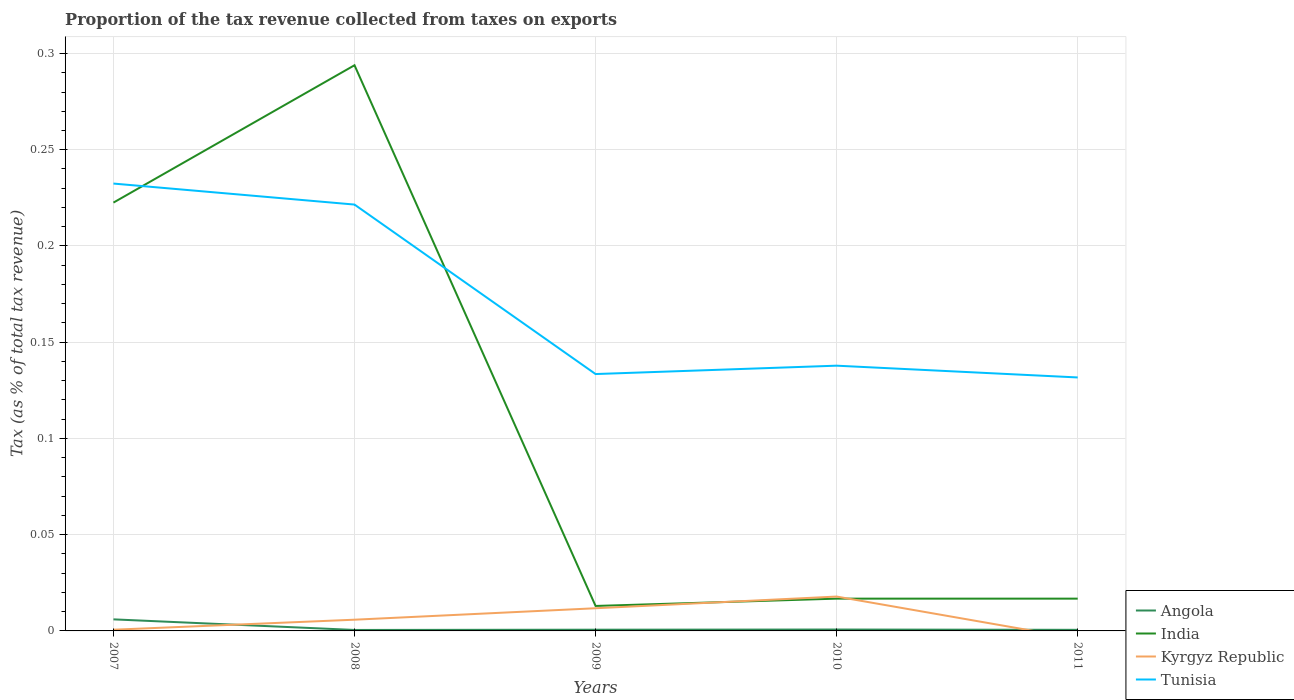Across all years, what is the maximum proportion of the tax revenue collected in Angola?
Ensure brevity in your answer.  0. What is the total proportion of the tax revenue collected in Tunisia in the graph?
Your answer should be very brief. -0. What is the difference between the highest and the second highest proportion of the tax revenue collected in Kyrgyz Republic?
Provide a short and direct response. 0.02. How many years are there in the graph?
Make the answer very short. 5. What is the difference between two consecutive major ticks on the Y-axis?
Keep it short and to the point. 0.05. Does the graph contain any zero values?
Offer a very short reply. Yes. Does the graph contain grids?
Offer a very short reply. Yes. Where does the legend appear in the graph?
Provide a short and direct response. Bottom right. How many legend labels are there?
Your response must be concise. 4. How are the legend labels stacked?
Your response must be concise. Vertical. What is the title of the graph?
Keep it short and to the point. Proportion of the tax revenue collected from taxes on exports. What is the label or title of the Y-axis?
Make the answer very short. Tax (as % of total tax revenue). What is the Tax (as % of total tax revenue) in Angola in 2007?
Provide a succinct answer. 0.01. What is the Tax (as % of total tax revenue) in India in 2007?
Offer a terse response. 0.22. What is the Tax (as % of total tax revenue) of Kyrgyz Republic in 2007?
Offer a very short reply. 0. What is the Tax (as % of total tax revenue) in Tunisia in 2007?
Give a very brief answer. 0.23. What is the Tax (as % of total tax revenue) in Angola in 2008?
Offer a very short reply. 0. What is the Tax (as % of total tax revenue) of India in 2008?
Provide a succinct answer. 0.29. What is the Tax (as % of total tax revenue) of Kyrgyz Republic in 2008?
Provide a short and direct response. 0.01. What is the Tax (as % of total tax revenue) of Tunisia in 2008?
Your answer should be very brief. 0.22. What is the Tax (as % of total tax revenue) of Angola in 2009?
Your answer should be compact. 0. What is the Tax (as % of total tax revenue) of India in 2009?
Keep it short and to the point. 0.01. What is the Tax (as % of total tax revenue) of Kyrgyz Republic in 2009?
Give a very brief answer. 0.01. What is the Tax (as % of total tax revenue) of Tunisia in 2009?
Provide a succinct answer. 0.13. What is the Tax (as % of total tax revenue) in Angola in 2010?
Provide a succinct answer. 0. What is the Tax (as % of total tax revenue) in India in 2010?
Keep it short and to the point. 0.02. What is the Tax (as % of total tax revenue) in Kyrgyz Republic in 2010?
Offer a very short reply. 0.02. What is the Tax (as % of total tax revenue) of Tunisia in 2010?
Your answer should be compact. 0.14. What is the Tax (as % of total tax revenue) of Angola in 2011?
Offer a terse response. 0. What is the Tax (as % of total tax revenue) in India in 2011?
Offer a terse response. 0.02. What is the Tax (as % of total tax revenue) in Kyrgyz Republic in 2011?
Ensure brevity in your answer.  0. What is the Tax (as % of total tax revenue) of Tunisia in 2011?
Make the answer very short. 0.13. Across all years, what is the maximum Tax (as % of total tax revenue) of Angola?
Provide a short and direct response. 0.01. Across all years, what is the maximum Tax (as % of total tax revenue) in India?
Ensure brevity in your answer.  0.29. Across all years, what is the maximum Tax (as % of total tax revenue) of Kyrgyz Republic?
Offer a terse response. 0.02. Across all years, what is the maximum Tax (as % of total tax revenue) of Tunisia?
Offer a very short reply. 0.23. Across all years, what is the minimum Tax (as % of total tax revenue) in Angola?
Ensure brevity in your answer.  0. Across all years, what is the minimum Tax (as % of total tax revenue) of India?
Offer a terse response. 0.01. Across all years, what is the minimum Tax (as % of total tax revenue) in Kyrgyz Republic?
Your answer should be compact. 0. Across all years, what is the minimum Tax (as % of total tax revenue) of Tunisia?
Provide a short and direct response. 0.13. What is the total Tax (as % of total tax revenue) of Angola in the graph?
Your answer should be very brief. 0.01. What is the total Tax (as % of total tax revenue) in India in the graph?
Provide a succinct answer. 0.56. What is the total Tax (as % of total tax revenue) in Kyrgyz Republic in the graph?
Your response must be concise. 0.04. What is the total Tax (as % of total tax revenue) in Tunisia in the graph?
Your answer should be very brief. 0.86. What is the difference between the Tax (as % of total tax revenue) of Angola in 2007 and that in 2008?
Ensure brevity in your answer.  0.01. What is the difference between the Tax (as % of total tax revenue) of India in 2007 and that in 2008?
Your answer should be compact. -0.07. What is the difference between the Tax (as % of total tax revenue) of Kyrgyz Republic in 2007 and that in 2008?
Provide a short and direct response. -0.01. What is the difference between the Tax (as % of total tax revenue) in Tunisia in 2007 and that in 2008?
Provide a short and direct response. 0.01. What is the difference between the Tax (as % of total tax revenue) in Angola in 2007 and that in 2009?
Provide a short and direct response. 0.01. What is the difference between the Tax (as % of total tax revenue) of India in 2007 and that in 2009?
Your answer should be compact. 0.21. What is the difference between the Tax (as % of total tax revenue) of Kyrgyz Republic in 2007 and that in 2009?
Provide a succinct answer. -0.01. What is the difference between the Tax (as % of total tax revenue) of Tunisia in 2007 and that in 2009?
Your answer should be compact. 0.1. What is the difference between the Tax (as % of total tax revenue) of Angola in 2007 and that in 2010?
Make the answer very short. 0.01. What is the difference between the Tax (as % of total tax revenue) in India in 2007 and that in 2010?
Your answer should be compact. 0.21. What is the difference between the Tax (as % of total tax revenue) of Kyrgyz Republic in 2007 and that in 2010?
Your response must be concise. -0.02. What is the difference between the Tax (as % of total tax revenue) in Tunisia in 2007 and that in 2010?
Keep it short and to the point. 0.09. What is the difference between the Tax (as % of total tax revenue) of Angola in 2007 and that in 2011?
Make the answer very short. 0.01. What is the difference between the Tax (as % of total tax revenue) in India in 2007 and that in 2011?
Make the answer very short. 0.21. What is the difference between the Tax (as % of total tax revenue) in Tunisia in 2007 and that in 2011?
Offer a terse response. 0.1. What is the difference between the Tax (as % of total tax revenue) in Angola in 2008 and that in 2009?
Your answer should be compact. -0. What is the difference between the Tax (as % of total tax revenue) in India in 2008 and that in 2009?
Offer a very short reply. 0.28. What is the difference between the Tax (as % of total tax revenue) in Kyrgyz Republic in 2008 and that in 2009?
Keep it short and to the point. -0.01. What is the difference between the Tax (as % of total tax revenue) of Tunisia in 2008 and that in 2009?
Your answer should be very brief. 0.09. What is the difference between the Tax (as % of total tax revenue) of Angola in 2008 and that in 2010?
Provide a short and direct response. -0. What is the difference between the Tax (as % of total tax revenue) in India in 2008 and that in 2010?
Offer a very short reply. 0.28. What is the difference between the Tax (as % of total tax revenue) in Kyrgyz Republic in 2008 and that in 2010?
Provide a succinct answer. -0.01. What is the difference between the Tax (as % of total tax revenue) of Tunisia in 2008 and that in 2010?
Offer a terse response. 0.08. What is the difference between the Tax (as % of total tax revenue) of Angola in 2008 and that in 2011?
Your answer should be compact. -0. What is the difference between the Tax (as % of total tax revenue) in India in 2008 and that in 2011?
Provide a short and direct response. 0.28. What is the difference between the Tax (as % of total tax revenue) in Tunisia in 2008 and that in 2011?
Make the answer very short. 0.09. What is the difference between the Tax (as % of total tax revenue) in Angola in 2009 and that in 2010?
Give a very brief answer. -0. What is the difference between the Tax (as % of total tax revenue) in India in 2009 and that in 2010?
Ensure brevity in your answer.  -0. What is the difference between the Tax (as % of total tax revenue) of Kyrgyz Republic in 2009 and that in 2010?
Ensure brevity in your answer.  -0.01. What is the difference between the Tax (as % of total tax revenue) in Tunisia in 2009 and that in 2010?
Offer a terse response. -0. What is the difference between the Tax (as % of total tax revenue) of Angola in 2009 and that in 2011?
Your answer should be compact. 0. What is the difference between the Tax (as % of total tax revenue) of India in 2009 and that in 2011?
Your response must be concise. -0. What is the difference between the Tax (as % of total tax revenue) in Tunisia in 2009 and that in 2011?
Keep it short and to the point. 0. What is the difference between the Tax (as % of total tax revenue) of Tunisia in 2010 and that in 2011?
Offer a very short reply. 0.01. What is the difference between the Tax (as % of total tax revenue) of Angola in 2007 and the Tax (as % of total tax revenue) of India in 2008?
Provide a succinct answer. -0.29. What is the difference between the Tax (as % of total tax revenue) in Angola in 2007 and the Tax (as % of total tax revenue) in Kyrgyz Republic in 2008?
Offer a very short reply. 0. What is the difference between the Tax (as % of total tax revenue) of Angola in 2007 and the Tax (as % of total tax revenue) of Tunisia in 2008?
Offer a very short reply. -0.22. What is the difference between the Tax (as % of total tax revenue) of India in 2007 and the Tax (as % of total tax revenue) of Kyrgyz Republic in 2008?
Offer a very short reply. 0.22. What is the difference between the Tax (as % of total tax revenue) in India in 2007 and the Tax (as % of total tax revenue) in Tunisia in 2008?
Offer a very short reply. 0. What is the difference between the Tax (as % of total tax revenue) in Kyrgyz Republic in 2007 and the Tax (as % of total tax revenue) in Tunisia in 2008?
Keep it short and to the point. -0.22. What is the difference between the Tax (as % of total tax revenue) in Angola in 2007 and the Tax (as % of total tax revenue) in India in 2009?
Offer a terse response. -0.01. What is the difference between the Tax (as % of total tax revenue) of Angola in 2007 and the Tax (as % of total tax revenue) of Kyrgyz Republic in 2009?
Your response must be concise. -0.01. What is the difference between the Tax (as % of total tax revenue) of Angola in 2007 and the Tax (as % of total tax revenue) of Tunisia in 2009?
Your answer should be compact. -0.13. What is the difference between the Tax (as % of total tax revenue) of India in 2007 and the Tax (as % of total tax revenue) of Kyrgyz Republic in 2009?
Offer a very short reply. 0.21. What is the difference between the Tax (as % of total tax revenue) in India in 2007 and the Tax (as % of total tax revenue) in Tunisia in 2009?
Offer a very short reply. 0.09. What is the difference between the Tax (as % of total tax revenue) of Kyrgyz Republic in 2007 and the Tax (as % of total tax revenue) of Tunisia in 2009?
Provide a short and direct response. -0.13. What is the difference between the Tax (as % of total tax revenue) of Angola in 2007 and the Tax (as % of total tax revenue) of India in 2010?
Your answer should be compact. -0.01. What is the difference between the Tax (as % of total tax revenue) of Angola in 2007 and the Tax (as % of total tax revenue) of Kyrgyz Republic in 2010?
Make the answer very short. -0.01. What is the difference between the Tax (as % of total tax revenue) in Angola in 2007 and the Tax (as % of total tax revenue) in Tunisia in 2010?
Offer a very short reply. -0.13. What is the difference between the Tax (as % of total tax revenue) in India in 2007 and the Tax (as % of total tax revenue) in Kyrgyz Republic in 2010?
Offer a terse response. 0.2. What is the difference between the Tax (as % of total tax revenue) in India in 2007 and the Tax (as % of total tax revenue) in Tunisia in 2010?
Provide a short and direct response. 0.08. What is the difference between the Tax (as % of total tax revenue) in Kyrgyz Republic in 2007 and the Tax (as % of total tax revenue) in Tunisia in 2010?
Offer a terse response. -0.14. What is the difference between the Tax (as % of total tax revenue) of Angola in 2007 and the Tax (as % of total tax revenue) of India in 2011?
Ensure brevity in your answer.  -0.01. What is the difference between the Tax (as % of total tax revenue) of Angola in 2007 and the Tax (as % of total tax revenue) of Tunisia in 2011?
Your response must be concise. -0.13. What is the difference between the Tax (as % of total tax revenue) of India in 2007 and the Tax (as % of total tax revenue) of Tunisia in 2011?
Offer a very short reply. 0.09. What is the difference between the Tax (as % of total tax revenue) in Kyrgyz Republic in 2007 and the Tax (as % of total tax revenue) in Tunisia in 2011?
Keep it short and to the point. -0.13. What is the difference between the Tax (as % of total tax revenue) in Angola in 2008 and the Tax (as % of total tax revenue) in India in 2009?
Your answer should be very brief. -0.01. What is the difference between the Tax (as % of total tax revenue) of Angola in 2008 and the Tax (as % of total tax revenue) of Kyrgyz Republic in 2009?
Offer a terse response. -0.01. What is the difference between the Tax (as % of total tax revenue) of Angola in 2008 and the Tax (as % of total tax revenue) of Tunisia in 2009?
Your answer should be very brief. -0.13. What is the difference between the Tax (as % of total tax revenue) in India in 2008 and the Tax (as % of total tax revenue) in Kyrgyz Republic in 2009?
Make the answer very short. 0.28. What is the difference between the Tax (as % of total tax revenue) in India in 2008 and the Tax (as % of total tax revenue) in Tunisia in 2009?
Offer a terse response. 0.16. What is the difference between the Tax (as % of total tax revenue) of Kyrgyz Republic in 2008 and the Tax (as % of total tax revenue) of Tunisia in 2009?
Your answer should be compact. -0.13. What is the difference between the Tax (as % of total tax revenue) in Angola in 2008 and the Tax (as % of total tax revenue) in India in 2010?
Provide a succinct answer. -0.02. What is the difference between the Tax (as % of total tax revenue) of Angola in 2008 and the Tax (as % of total tax revenue) of Kyrgyz Republic in 2010?
Your answer should be very brief. -0.02. What is the difference between the Tax (as % of total tax revenue) of Angola in 2008 and the Tax (as % of total tax revenue) of Tunisia in 2010?
Ensure brevity in your answer.  -0.14. What is the difference between the Tax (as % of total tax revenue) of India in 2008 and the Tax (as % of total tax revenue) of Kyrgyz Republic in 2010?
Make the answer very short. 0.28. What is the difference between the Tax (as % of total tax revenue) of India in 2008 and the Tax (as % of total tax revenue) of Tunisia in 2010?
Make the answer very short. 0.16. What is the difference between the Tax (as % of total tax revenue) of Kyrgyz Republic in 2008 and the Tax (as % of total tax revenue) of Tunisia in 2010?
Your answer should be very brief. -0.13. What is the difference between the Tax (as % of total tax revenue) of Angola in 2008 and the Tax (as % of total tax revenue) of India in 2011?
Your response must be concise. -0.02. What is the difference between the Tax (as % of total tax revenue) of Angola in 2008 and the Tax (as % of total tax revenue) of Tunisia in 2011?
Give a very brief answer. -0.13. What is the difference between the Tax (as % of total tax revenue) in India in 2008 and the Tax (as % of total tax revenue) in Tunisia in 2011?
Provide a short and direct response. 0.16. What is the difference between the Tax (as % of total tax revenue) in Kyrgyz Republic in 2008 and the Tax (as % of total tax revenue) in Tunisia in 2011?
Ensure brevity in your answer.  -0.13. What is the difference between the Tax (as % of total tax revenue) in Angola in 2009 and the Tax (as % of total tax revenue) in India in 2010?
Make the answer very short. -0.02. What is the difference between the Tax (as % of total tax revenue) of Angola in 2009 and the Tax (as % of total tax revenue) of Kyrgyz Republic in 2010?
Keep it short and to the point. -0.02. What is the difference between the Tax (as % of total tax revenue) in Angola in 2009 and the Tax (as % of total tax revenue) in Tunisia in 2010?
Offer a very short reply. -0.14. What is the difference between the Tax (as % of total tax revenue) of India in 2009 and the Tax (as % of total tax revenue) of Kyrgyz Republic in 2010?
Your answer should be compact. -0. What is the difference between the Tax (as % of total tax revenue) in India in 2009 and the Tax (as % of total tax revenue) in Tunisia in 2010?
Ensure brevity in your answer.  -0.12. What is the difference between the Tax (as % of total tax revenue) of Kyrgyz Republic in 2009 and the Tax (as % of total tax revenue) of Tunisia in 2010?
Ensure brevity in your answer.  -0.13. What is the difference between the Tax (as % of total tax revenue) in Angola in 2009 and the Tax (as % of total tax revenue) in India in 2011?
Provide a short and direct response. -0.02. What is the difference between the Tax (as % of total tax revenue) in Angola in 2009 and the Tax (as % of total tax revenue) in Tunisia in 2011?
Your response must be concise. -0.13. What is the difference between the Tax (as % of total tax revenue) of India in 2009 and the Tax (as % of total tax revenue) of Tunisia in 2011?
Your response must be concise. -0.12. What is the difference between the Tax (as % of total tax revenue) of Kyrgyz Republic in 2009 and the Tax (as % of total tax revenue) of Tunisia in 2011?
Your answer should be compact. -0.12. What is the difference between the Tax (as % of total tax revenue) of Angola in 2010 and the Tax (as % of total tax revenue) of India in 2011?
Offer a terse response. -0.02. What is the difference between the Tax (as % of total tax revenue) in Angola in 2010 and the Tax (as % of total tax revenue) in Tunisia in 2011?
Provide a short and direct response. -0.13. What is the difference between the Tax (as % of total tax revenue) of India in 2010 and the Tax (as % of total tax revenue) of Tunisia in 2011?
Provide a succinct answer. -0.11. What is the difference between the Tax (as % of total tax revenue) of Kyrgyz Republic in 2010 and the Tax (as % of total tax revenue) of Tunisia in 2011?
Provide a succinct answer. -0.11. What is the average Tax (as % of total tax revenue) in Angola per year?
Keep it short and to the point. 0. What is the average Tax (as % of total tax revenue) of India per year?
Provide a succinct answer. 0.11. What is the average Tax (as % of total tax revenue) of Kyrgyz Republic per year?
Your answer should be compact. 0.01. What is the average Tax (as % of total tax revenue) in Tunisia per year?
Ensure brevity in your answer.  0.17. In the year 2007, what is the difference between the Tax (as % of total tax revenue) of Angola and Tax (as % of total tax revenue) of India?
Give a very brief answer. -0.22. In the year 2007, what is the difference between the Tax (as % of total tax revenue) in Angola and Tax (as % of total tax revenue) in Kyrgyz Republic?
Your response must be concise. 0.01. In the year 2007, what is the difference between the Tax (as % of total tax revenue) of Angola and Tax (as % of total tax revenue) of Tunisia?
Make the answer very short. -0.23. In the year 2007, what is the difference between the Tax (as % of total tax revenue) in India and Tax (as % of total tax revenue) in Kyrgyz Republic?
Make the answer very short. 0.22. In the year 2007, what is the difference between the Tax (as % of total tax revenue) in India and Tax (as % of total tax revenue) in Tunisia?
Your answer should be compact. -0.01. In the year 2007, what is the difference between the Tax (as % of total tax revenue) in Kyrgyz Republic and Tax (as % of total tax revenue) in Tunisia?
Provide a short and direct response. -0.23. In the year 2008, what is the difference between the Tax (as % of total tax revenue) of Angola and Tax (as % of total tax revenue) of India?
Make the answer very short. -0.29. In the year 2008, what is the difference between the Tax (as % of total tax revenue) of Angola and Tax (as % of total tax revenue) of Kyrgyz Republic?
Your answer should be very brief. -0.01. In the year 2008, what is the difference between the Tax (as % of total tax revenue) of Angola and Tax (as % of total tax revenue) of Tunisia?
Provide a succinct answer. -0.22. In the year 2008, what is the difference between the Tax (as % of total tax revenue) in India and Tax (as % of total tax revenue) in Kyrgyz Republic?
Make the answer very short. 0.29. In the year 2008, what is the difference between the Tax (as % of total tax revenue) in India and Tax (as % of total tax revenue) in Tunisia?
Give a very brief answer. 0.07. In the year 2008, what is the difference between the Tax (as % of total tax revenue) in Kyrgyz Republic and Tax (as % of total tax revenue) in Tunisia?
Provide a succinct answer. -0.22. In the year 2009, what is the difference between the Tax (as % of total tax revenue) in Angola and Tax (as % of total tax revenue) in India?
Offer a very short reply. -0.01. In the year 2009, what is the difference between the Tax (as % of total tax revenue) of Angola and Tax (as % of total tax revenue) of Kyrgyz Republic?
Give a very brief answer. -0.01. In the year 2009, what is the difference between the Tax (as % of total tax revenue) in Angola and Tax (as % of total tax revenue) in Tunisia?
Give a very brief answer. -0.13. In the year 2009, what is the difference between the Tax (as % of total tax revenue) of India and Tax (as % of total tax revenue) of Kyrgyz Republic?
Provide a short and direct response. 0. In the year 2009, what is the difference between the Tax (as % of total tax revenue) in India and Tax (as % of total tax revenue) in Tunisia?
Keep it short and to the point. -0.12. In the year 2009, what is the difference between the Tax (as % of total tax revenue) of Kyrgyz Republic and Tax (as % of total tax revenue) of Tunisia?
Provide a succinct answer. -0.12. In the year 2010, what is the difference between the Tax (as % of total tax revenue) of Angola and Tax (as % of total tax revenue) of India?
Ensure brevity in your answer.  -0.02. In the year 2010, what is the difference between the Tax (as % of total tax revenue) in Angola and Tax (as % of total tax revenue) in Kyrgyz Republic?
Give a very brief answer. -0.02. In the year 2010, what is the difference between the Tax (as % of total tax revenue) of Angola and Tax (as % of total tax revenue) of Tunisia?
Your answer should be compact. -0.14. In the year 2010, what is the difference between the Tax (as % of total tax revenue) in India and Tax (as % of total tax revenue) in Kyrgyz Republic?
Provide a succinct answer. -0. In the year 2010, what is the difference between the Tax (as % of total tax revenue) of India and Tax (as % of total tax revenue) of Tunisia?
Your response must be concise. -0.12. In the year 2010, what is the difference between the Tax (as % of total tax revenue) of Kyrgyz Republic and Tax (as % of total tax revenue) of Tunisia?
Your answer should be compact. -0.12. In the year 2011, what is the difference between the Tax (as % of total tax revenue) of Angola and Tax (as % of total tax revenue) of India?
Provide a short and direct response. -0.02. In the year 2011, what is the difference between the Tax (as % of total tax revenue) in Angola and Tax (as % of total tax revenue) in Tunisia?
Provide a succinct answer. -0.13. In the year 2011, what is the difference between the Tax (as % of total tax revenue) of India and Tax (as % of total tax revenue) of Tunisia?
Your answer should be very brief. -0.11. What is the ratio of the Tax (as % of total tax revenue) of Angola in 2007 to that in 2008?
Your answer should be very brief. 11.89. What is the ratio of the Tax (as % of total tax revenue) of India in 2007 to that in 2008?
Your answer should be very brief. 0.76. What is the ratio of the Tax (as % of total tax revenue) in Kyrgyz Republic in 2007 to that in 2008?
Offer a very short reply. 0.11. What is the ratio of the Tax (as % of total tax revenue) in Tunisia in 2007 to that in 2008?
Give a very brief answer. 1.05. What is the ratio of the Tax (as % of total tax revenue) of Angola in 2007 to that in 2009?
Your answer should be compact. 9.5. What is the ratio of the Tax (as % of total tax revenue) in India in 2007 to that in 2009?
Give a very brief answer. 17.16. What is the ratio of the Tax (as % of total tax revenue) of Kyrgyz Republic in 2007 to that in 2009?
Your answer should be very brief. 0.05. What is the ratio of the Tax (as % of total tax revenue) in Tunisia in 2007 to that in 2009?
Your answer should be compact. 1.74. What is the ratio of the Tax (as % of total tax revenue) in Angola in 2007 to that in 2010?
Provide a succinct answer. 8.31. What is the ratio of the Tax (as % of total tax revenue) in India in 2007 to that in 2010?
Offer a terse response. 13.27. What is the ratio of the Tax (as % of total tax revenue) of Kyrgyz Republic in 2007 to that in 2010?
Provide a succinct answer. 0.04. What is the ratio of the Tax (as % of total tax revenue) in Tunisia in 2007 to that in 2010?
Provide a short and direct response. 1.69. What is the ratio of the Tax (as % of total tax revenue) of Angola in 2007 to that in 2011?
Keep it short and to the point. 10.54. What is the ratio of the Tax (as % of total tax revenue) of India in 2007 to that in 2011?
Provide a short and direct response. 13.27. What is the ratio of the Tax (as % of total tax revenue) in Tunisia in 2007 to that in 2011?
Your answer should be very brief. 1.76. What is the ratio of the Tax (as % of total tax revenue) in Angola in 2008 to that in 2009?
Offer a very short reply. 0.8. What is the ratio of the Tax (as % of total tax revenue) in India in 2008 to that in 2009?
Offer a very short reply. 22.66. What is the ratio of the Tax (as % of total tax revenue) in Kyrgyz Republic in 2008 to that in 2009?
Offer a very short reply. 0.49. What is the ratio of the Tax (as % of total tax revenue) of Tunisia in 2008 to that in 2009?
Offer a terse response. 1.66. What is the ratio of the Tax (as % of total tax revenue) of Angola in 2008 to that in 2010?
Keep it short and to the point. 0.7. What is the ratio of the Tax (as % of total tax revenue) in India in 2008 to that in 2010?
Keep it short and to the point. 17.53. What is the ratio of the Tax (as % of total tax revenue) in Kyrgyz Republic in 2008 to that in 2010?
Your response must be concise. 0.33. What is the ratio of the Tax (as % of total tax revenue) in Tunisia in 2008 to that in 2010?
Your response must be concise. 1.61. What is the ratio of the Tax (as % of total tax revenue) in Angola in 2008 to that in 2011?
Provide a short and direct response. 0.89. What is the ratio of the Tax (as % of total tax revenue) of India in 2008 to that in 2011?
Make the answer very short. 17.53. What is the ratio of the Tax (as % of total tax revenue) of Tunisia in 2008 to that in 2011?
Provide a short and direct response. 1.68. What is the ratio of the Tax (as % of total tax revenue) in Angola in 2009 to that in 2010?
Your response must be concise. 0.87. What is the ratio of the Tax (as % of total tax revenue) of India in 2009 to that in 2010?
Give a very brief answer. 0.77. What is the ratio of the Tax (as % of total tax revenue) in Kyrgyz Republic in 2009 to that in 2010?
Offer a terse response. 0.66. What is the ratio of the Tax (as % of total tax revenue) of Tunisia in 2009 to that in 2010?
Make the answer very short. 0.97. What is the ratio of the Tax (as % of total tax revenue) of Angola in 2009 to that in 2011?
Your response must be concise. 1.11. What is the ratio of the Tax (as % of total tax revenue) in India in 2009 to that in 2011?
Give a very brief answer. 0.77. What is the ratio of the Tax (as % of total tax revenue) of Tunisia in 2009 to that in 2011?
Your answer should be compact. 1.01. What is the ratio of the Tax (as % of total tax revenue) in Angola in 2010 to that in 2011?
Your answer should be compact. 1.27. What is the ratio of the Tax (as % of total tax revenue) of India in 2010 to that in 2011?
Make the answer very short. 1. What is the ratio of the Tax (as % of total tax revenue) in Tunisia in 2010 to that in 2011?
Offer a very short reply. 1.05. What is the difference between the highest and the second highest Tax (as % of total tax revenue) of Angola?
Your response must be concise. 0.01. What is the difference between the highest and the second highest Tax (as % of total tax revenue) in India?
Provide a short and direct response. 0.07. What is the difference between the highest and the second highest Tax (as % of total tax revenue) of Kyrgyz Republic?
Ensure brevity in your answer.  0.01. What is the difference between the highest and the second highest Tax (as % of total tax revenue) of Tunisia?
Provide a short and direct response. 0.01. What is the difference between the highest and the lowest Tax (as % of total tax revenue) in Angola?
Offer a very short reply. 0.01. What is the difference between the highest and the lowest Tax (as % of total tax revenue) in India?
Offer a very short reply. 0.28. What is the difference between the highest and the lowest Tax (as % of total tax revenue) of Kyrgyz Republic?
Give a very brief answer. 0.02. What is the difference between the highest and the lowest Tax (as % of total tax revenue) of Tunisia?
Your answer should be compact. 0.1. 